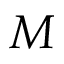Convert formula to latex. <formula><loc_0><loc_0><loc_500><loc_500>M</formula> 